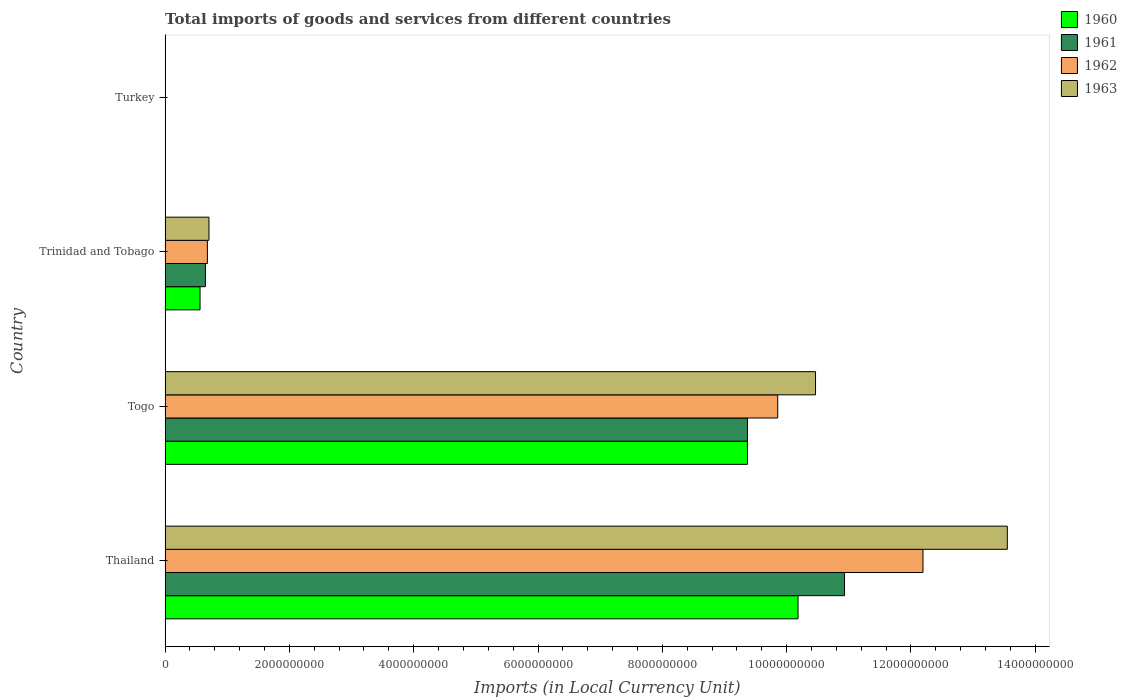Are the number of bars on each tick of the Y-axis equal?
Keep it short and to the point. Yes. How many bars are there on the 1st tick from the bottom?
Provide a succinct answer. 4. What is the label of the 3rd group of bars from the top?
Your response must be concise. Togo. What is the Amount of goods and services imports in 1960 in Togo?
Offer a terse response. 9.37e+09. Across all countries, what is the maximum Amount of goods and services imports in 1962?
Ensure brevity in your answer.  1.22e+1. Across all countries, what is the minimum Amount of goods and services imports in 1963?
Provide a short and direct response. 6500. In which country was the Amount of goods and services imports in 1960 maximum?
Provide a short and direct response. Thailand. In which country was the Amount of goods and services imports in 1961 minimum?
Make the answer very short. Turkey. What is the total Amount of goods and services imports in 1962 in the graph?
Offer a terse response. 2.27e+1. What is the difference between the Amount of goods and services imports in 1963 in Thailand and that in Trinidad and Tobago?
Your answer should be compact. 1.28e+1. What is the difference between the Amount of goods and services imports in 1960 in Turkey and the Amount of goods and services imports in 1962 in Thailand?
Make the answer very short. -1.22e+1. What is the average Amount of goods and services imports in 1960 per country?
Your answer should be compact. 5.03e+09. What is the difference between the Amount of goods and services imports in 1961 and Amount of goods and services imports in 1962 in Trinidad and Tobago?
Offer a very short reply. -3.17e+07. In how many countries, is the Amount of goods and services imports in 1963 greater than 9200000000 LCU?
Your response must be concise. 2. What is the ratio of the Amount of goods and services imports in 1960 in Thailand to that in Togo?
Give a very brief answer. 1.09. Is the difference between the Amount of goods and services imports in 1961 in Thailand and Trinidad and Tobago greater than the difference between the Amount of goods and services imports in 1962 in Thailand and Trinidad and Tobago?
Provide a succinct answer. No. What is the difference between the highest and the second highest Amount of goods and services imports in 1960?
Ensure brevity in your answer.  8.14e+08. What is the difference between the highest and the lowest Amount of goods and services imports in 1961?
Make the answer very short. 1.09e+1. In how many countries, is the Amount of goods and services imports in 1961 greater than the average Amount of goods and services imports in 1961 taken over all countries?
Your answer should be very brief. 2. Is the sum of the Amount of goods and services imports in 1962 in Trinidad and Tobago and Turkey greater than the maximum Amount of goods and services imports in 1961 across all countries?
Make the answer very short. No. Is it the case that in every country, the sum of the Amount of goods and services imports in 1961 and Amount of goods and services imports in 1962 is greater than the sum of Amount of goods and services imports in 1963 and Amount of goods and services imports in 1960?
Provide a succinct answer. No. What does the 3rd bar from the top in Trinidad and Tobago represents?
Keep it short and to the point. 1961. Are all the bars in the graph horizontal?
Make the answer very short. Yes. Are the values on the major ticks of X-axis written in scientific E-notation?
Your answer should be compact. No. Does the graph contain any zero values?
Your response must be concise. No. Does the graph contain grids?
Provide a short and direct response. No. How many legend labels are there?
Your answer should be very brief. 4. How are the legend labels stacked?
Offer a terse response. Vertical. What is the title of the graph?
Make the answer very short. Total imports of goods and services from different countries. Does "2002" appear as one of the legend labels in the graph?
Provide a succinct answer. No. What is the label or title of the X-axis?
Make the answer very short. Imports (in Local Currency Unit). What is the Imports (in Local Currency Unit) of 1960 in Thailand?
Your answer should be very brief. 1.02e+1. What is the Imports (in Local Currency Unit) of 1961 in Thailand?
Offer a terse response. 1.09e+1. What is the Imports (in Local Currency Unit) in 1962 in Thailand?
Provide a short and direct response. 1.22e+1. What is the Imports (in Local Currency Unit) of 1963 in Thailand?
Provide a succinct answer. 1.36e+1. What is the Imports (in Local Currency Unit) of 1960 in Togo?
Provide a short and direct response. 9.37e+09. What is the Imports (in Local Currency Unit) in 1961 in Togo?
Provide a short and direct response. 9.37e+09. What is the Imports (in Local Currency Unit) in 1962 in Togo?
Your answer should be compact. 9.86e+09. What is the Imports (in Local Currency Unit) of 1963 in Togo?
Your answer should be very brief. 1.05e+1. What is the Imports (in Local Currency Unit) of 1960 in Trinidad and Tobago?
Offer a terse response. 5.62e+08. What is the Imports (in Local Currency Unit) of 1961 in Trinidad and Tobago?
Your answer should be compact. 6.49e+08. What is the Imports (in Local Currency Unit) of 1962 in Trinidad and Tobago?
Your response must be concise. 6.81e+08. What is the Imports (in Local Currency Unit) in 1963 in Trinidad and Tobago?
Give a very brief answer. 7.06e+08. What is the Imports (in Local Currency Unit) of 1960 in Turkey?
Your response must be concise. 2500. What is the Imports (in Local Currency Unit) of 1961 in Turkey?
Keep it short and to the point. 4900. What is the Imports (in Local Currency Unit) of 1962 in Turkey?
Ensure brevity in your answer.  6400. What is the Imports (in Local Currency Unit) in 1963 in Turkey?
Offer a terse response. 6500. Across all countries, what is the maximum Imports (in Local Currency Unit) in 1960?
Offer a very short reply. 1.02e+1. Across all countries, what is the maximum Imports (in Local Currency Unit) of 1961?
Your answer should be very brief. 1.09e+1. Across all countries, what is the maximum Imports (in Local Currency Unit) in 1962?
Ensure brevity in your answer.  1.22e+1. Across all countries, what is the maximum Imports (in Local Currency Unit) in 1963?
Offer a terse response. 1.36e+1. Across all countries, what is the minimum Imports (in Local Currency Unit) in 1960?
Keep it short and to the point. 2500. Across all countries, what is the minimum Imports (in Local Currency Unit) of 1961?
Your answer should be very brief. 4900. Across all countries, what is the minimum Imports (in Local Currency Unit) in 1962?
Ensure brevity in your answer.  6400. Across all countries, what is the minimum Imports (in Local Currency Unit) in 1963?
Give a very brief answer. 6500. What is the total Imports (in Local Currency Unit) in 1960 in the graph?
Keep it short and to the point. 2.01e+1. What is the total Imports (in Local Currency Unit) in 1961 in the graph?
Ensure brevity in your answer.  2.10e+1. What is the total Imports (in Local Currency Unit) of 1962 in the graph?
Offer a very short reply. 2.27e+1. What is the total Imports (in Local Currency Unit) of 1963 in the graph?
Your answer should be compact. 2.47e+1. What is the difference between the Imports (in Local Currency Unit) in 1960 in Thailand and that in Togo?
Ensure brevity in your answer.  8.14e+08. What is the difference between the Imports (in Local Currency Unit) in 1961 in Thailand and that in Togo?
Make the answer very short. 1.56e+09. What is the difference between the Imports (in Local Currency Unit) of 1962 in Thailand and that in Togo?
Provide a succinct answer. 2.34e+09. What is the difference between the Imports (in Local Currency Unit) in 1963 in Thailand and that in Togo?
Your answer should be very brief. 3.09e+09. What is the difference between the Imports (in Local Currency Unit) in 1960 in Thailand and that in Trinidad and Tobago?
Your answer should be compact. 9.62e+09. What is the difference between the Imports (in Local Currency Unit) of 1961 in Thailand and that in Trinidad and Tobago?
Your answer should be very brief. 1.03e+1. What is the difference between the Imports (in Local Currency Unit) of 1962 in Thailand and that in Trinidad and Tobago?
Your answer should be very brief. 1.15e+1. What is the difference between the Imports (in Local Currency Unit) in 1963 in Thailand and that in Trinidad and Tobago?
Give a very brief answer. 1.28e+1. What is the difference between the Imports (in Local Currency Unit) in 1960 in Thailand and that in Turkey?
Make the answer very short. 1.02e+1. What is the difference between the Imports (in Local Currency Unit) in 1961 in Thailand and that in Turkey?
Your answer should be compact. 1.09e+1. What is the difference between the Imports (in Local Currency Unit) of 1962 in Thailand and that in Turkey?
Make the answer very short. 1.22e+1. What is the difference between the Imports (in Local Currency Unit) in 1963 in Thailand and that in Turkey?
Offer a terse response. 1.36e+1. What is the difference between the Imports (in Local Currency Unit) in 1960 in Togo and that in Trinidad and Tobago?
Your answer should be compact. 8.81e+09. What is the difference between the Imports (in Local Currency Unit) of 1961 in Togo and that in Trinidad and Tobago?
Provide a succinct answer. 8.72e+09. What is the difference between the Imports (in Local Currency Unit) in 1962 in Togo and that in Trinidad and Tobago?
Give a very brief answer. 9.18e+09. What is the difference between the Imports (in Local Currency Unit) of 1963 in Togo and that in Trinidad and Tobago?
Ensure brevity in your answer.  9.76e+09. What is the difference between the Imports (in Local Currency Unit) in 1960 in Togo and that in Turkey?
Provide a short and direct response. 9.37e+09. What is the difference between the Imports (in Local Currency Unit) in 1961 in Togo and that in Turkey?
Keep it short and to the point. 9.37e+09. What is the difference between the Imports (in Local Currency Unit) in 1962 in Togo and that in Turkey?
Your answer should be compact. 9.86e+09. What is the difference between the Imports (in Local Currency Unit) in 1963 in Togo and that in Turkey?
Make the answer very short. 1.05e+1. What is the difference between the Imports (in Local Currency Unit) of 1960 in Trinidad and Tobago and that in Turkey?
Your answer should be compact. 5.62e+08. What is the difference between the Imports (in Local Currency Unit) in 1961 in Trinidad and Tobago and that in Turkey?
Make the answer very short. 6.49e+08. What is the difference between the Imports (in Local Currency Unit) of 1962 in Trinidad and Tobago and that in Turkey?
Your answer should be compact. 6.81e+08. What is the difference between the Imports (in Local Currency Unit) of 1963 in Trinidad and Tobago and that in Turkey?
Your answer should be compact. 7.06e+08. What is the difference between the Imports (in Local Currency Unit) in 1960 in Thailand and the Imports (in Local Currency Unit) in 1961 in Togo?
Keep it short and to the point. 8.14e+08. What is the difference between the Imports (in Local Currency Unit) of 1960 in Thailand and the Imports (in Local Currency Unit) of 1962 in Togo?
Provide a succinct answer. 3.27e+08. What is the difference between the Imports (in Local Currency Unit) of 1960 in Thailand and the Imports (in Local Currency Unit) of 1963 in Togo?
Provide a short and direct response. -2.81e+08. What is the difference between the Imports (in Local Currency Unit) in 1961 in Thailand and the Imports (in Local Currency Unit) in 1962 in Togo?
Offer a terse response. 1.08e+09. What is the difference between the Imports (in Local Currency Unit) of 1961 in Thailand and the Imports (in Local Currency Unit) of 1963 in Togo?
Your answer should be compact. 4.67e+08. What is the difference between the Imports (in Local Currency Unit) in 1962 in Thailand and the Imports (in Local Currency Unit) in 1963 in Togo?
Provide a short and direct response. 1.73e+09. What is the difference between the Imports (in Local Currency Unit) of 1960 in Thailand and the Imports (in Local Currency Unit) of 1961 in Trinidad and Tobago?
Your answer should be compact. 9.54e+09. What is the difference between the Imports (in Local Currency Unit) in 1960 in Thailand and the Imports (in Local Currency Unit) in 1962 in Trinidad and Tobago?
Offer a very short reply. 9.50e+09. What is the difference between the Imports (in Local Currency Unit) of 1960 in Thailand and the Imports (in Local Currency Unit) of 1963 in Trinidad and Tobago?
Offer a very short reply. 9.48e+09. What is the difference between the Imports (in Local Currency Unit) of 1961 in Thailand and the Imports (in Local Currency Unit) of 1962 in Trinidad and Tobago?
Provide a short and direct response. 1.03e+1. What is the difference between the Imports (in Local Currency Unit) of 1961 in Thailand and the Imports (in Local Currency Unit) of 1963 in Trinidad and Tobago?
Your response must be concise. 1.02e+1. What is the difference between the Imports (in Local Currency Unit) of 1962 in Thailand and the Imports (in Local Currency Unit) of 1963 in Trinidad and Tobago?
Keep it short and to the point. 1.15e+1. What is the difference between the Imports (in Local Currency Unit) of 1960 in Thailand and the Imports (in Local Currency Unit) of 1961 in Turkey?
Provide a short and direct response. 1.02e+1. What is the difference between the Imports (in Local Currency Unit) of 1960 in Thailand and the Imports (in Local Currency Unit) of 1962 in Turkey?
Your response must be concise. 1.02e+1. What is the difference between the Imports (in Local Currency Unit) in 1960 in Thailand and the Imports (in Local Currency Unit) in 1963 in Turkey?
Your answer should be very brief. 1.02e+1. What is the difference between the Imports (in Local Currency Unit) in 1961 in Thailand and the Imports (in Local Currency Unit) in 1962 in Turkey?
Provide a short and direct response. 1.09e+1. What is the difference between the Imports (in Local Currency Unit) of 1961 in Thailand and the Imports (in Local Currency Unit) of 1963 in Turkey?
Provide a succinct answer. 1.09e+1. What is the difference between the Imports (in Local Currency Unit) of 1962 in Thailand and the Imports (in Local Currency Unit) of 1963 in Turkey?
Offer a terse response. 1.22e+1. What is the difference between the Imports (in Local Currency Unit) in 1960 in Togo and the Imports (in Local Currency Unit) in 1961 in Trinidad and Tobago?
Your answer should be compact. 8.72e+09. What is the difference between the Imports (in Local Currency Unit) in 1960 in Togo and the Imports (in Local Currency Unit) in 1962 in Trinidad and Tobago?
Offer a terse response. 8.69e+09. What is the difference between the Imports (in Local Currency Unit) of 1960 in Togo and the Imports (in Local Currency Unit) of 1963 in Trinidad and Tobago?
Keep it short and to the point. 8.66e+09. What is the difference between the Imports (in Local Currency Unit) in 1961 in Togo and the Imports (in Local Currency Unit) in 1962 in Trinidad and Tobago?
Offer a terse response. 8.69e+09. What is the difference between the Imports (in Local Currency Unit) of 1961 in Togo and the Imports (in Local Currency Unit) of 1963 in Trinidad and Tobago?
Keep it short and to the point. 8.66e+09. What is the difference between the Imports (in Local Currency Unit) in 1962 in Togo and the Imports (in Local Currency Unit) in 1963 in Trinidad and Tobago?
Your answer should be compact. 9.15e+09. What is the difference between the Imports (in Local Currency Unit) in 1960 in Togo and the Imports (in Local Currency Unit) in 1961 in Turkey?
Give a very brief answer. 9.37e+09. What is the difference between the Imports (in Local Currency Unit) of 1960 in Togo and the Imports (in Local Currency Unit) of 1962 in Turkey?
Offer a terse response. 9.37e+09. What is the difference between the Imports (in Local Currency Unit) of 1960 in Togo and the Imports (in Local Currency Unit) of 1963 in Turkey?
Offer a terse response. 9.37e+09. What is the difference between the Imports (in Local Currency Unit) in 1961 in Togo and the Imports (in Local Currency Unit) in 1962 in Turkey?
Keep it short and to the point. 9.37e+09. What is the difference between the Imports (in Local Currency Unit) of 1961 in Togo and the Imports (in Local Currency Unit) of 1963 in Turkey?
Your response must be concise. 9.37e+09. What is the difference between the Imports (in Local Currency Unit) of 1962 in Togo and the Imports (in Local Currency Unit) of 1963 in Turkey?
Your response must be concise. 9.86e+09. What is the difference between the Imports (in Local Currency Unit) in 1960 in Trinidad and Tobago and the Imports (in Local Currency Unit) in 1961 in Turkey?
Keep it short and to the point. 5.62e+08. What is the difference between the Imports (in Local Currency Unit) of 1960 in Trinidad and Tobago and the Imports (in Local Currency Unit) of 1962 in Turkey?
Your response must be concise. 5.62e+08. What is the difference between the Imports (in Local Currency Unit) of 1960 in Trinidad and Tobago and the Imports (in Local Currency Unit) of 1963 in Turkey?
Offer a very short reply. 5.62e+08. What is the difference between the Imports (in Local Currency Unit) in 1961 in Trinidad and Tobago and the Imports (in Local Currency Unit) in 1962 in Turkey?
Make the answer very short. 6.49e+08. What is the difference between the Imports (in Local Currency Unit) of 1961 in Trinidad and Tobago and the Imports (in Local Currency Unit) of 1963 in Turkey?
Offer a very short reply. 6.49e+08. What is the difference between the Imports (in Local Currency Unit) in 1962 in Trinidad and Tobago and the Imports (in Local Currency Unit) in 1963 in Turkey?
Provide a short and direct response. 6.81e+08. What is the average Imports (in Local Currency Unit) in 1960 per country?
Your answer should be compact. 5.03e+09. What is the average Imports (in Local Currency Unit) of 1961 per country?
Offer a terse response. 5.24e+09. What is the average Imports (in Local Currency Unit) of 1962 per country?
Make the answer very short. 5.68e+09. What is the average Imports (in Local Currency Unit) of 1963 per country?
Your answer should be very brief. 6.18e+09. What is the difference between the Imports (in Local Currency Unit) of 1960 and Imports (in Local Currency Unit) of 1961 in Thailand?
Make the answer very short. -7.48e+08. What is the difference between the Imports (in Local Currency Unit) in 1960 and Imports (in Local Currency Unit) in 1962 in Thailand?
Offer a terse response. -2.01e+09. What is the difference between the Imports (in Local Currency Unit) in 1960 and Imports (in Local Currency Unit) in 1963 in Thailand?
Your answer should be very brief. -3.37e+09. What is the difference between the Imports (in Local Currency Unit) in 1961 and Imports (in Local Currency Unit) in 1962 in Thailand?
Your response must be concise. -1.26e+09. What is the difference between the Imports (in Local Currency Unit) of 1961 and Imports (in Local Currency Unit) of 1963 in Thailand?
Your answer should be compact. -2.62e+09. What is the difference between the Imports (in Local Currency Unit) in 1962 and Imports (in Local Currency Unit) in 1963 in Thailand?
Your answer should be compact. -1.36e+09. What is the difference between the Imports (in Local Currency Unit) in 1960 and Imports (in Local Currency Unit) in 1962 in Togo?
Offer a terse response. -4.87e+08. What is the difference between the Imports (in Local Currency Unit) in 1960 and Imports (in Local Currency Unit) in 1963 in Togo?
Make the answer very short. -1.10e+09. What is the difference between the Imports (in Local Currency Unit) in 1961 and Imports (in Local Currency Unit) in 1962 in Togo?
Keep it short and to the point. -4.87e+08. What is the difference between the Imports (in Local Currency Unit) in 1961 and Imports (in Local Currency Unit) in 1963 in Togo?
Keep it short and to the point. -1.10e+09. What is the difference between the Imports (in Local Currency Unit) of 1962 and Imports (in Local Currency Unit) of 1963 in Togo?
Your answer should be very brief. -6.08e+08. What is the difference between the Imports (in Local Currency Unit) in 1960 and Imports (in Local Currency Unit) in 1961 in Trinidad and Tobago?
Provide a succinct answer. -8.67e+07. What is the difference between the Imports (in Local Currency Unit) of 1960 and Imports (in Local Currency Unit) of 1962 in Trinidad and Tobago?
Offer a very short reply. -1.18e+08. What is the difference between the Imports (in Local Currency Unit) of 1960 and Imports (in Local Currency Unit) of 1963 in Trinidad and Tobago?
Make the answer very short. -1.44e+08. What is the difference between the Imports (in Local Currency Unit) in 1961 and Imports (in Local Currency Unit) in 1962 in Trinidad and Tobago?
Provide a succinct answer. -3.17e+07. What is the difference between the Imports (in Local Currency Unit) in 1961 and Imports (in Local Currency Unit) in 1963 in Trinidad and Tobago?
Keep it short and to the point. -5.69e+07. What is the difference between the Imports (in Local Currency Unit) of 1962 and Imports (in Local Currency Unit) of 1963 in Trinidad and Tobago?
Provide a succinct answer. -2.52e+07. What is the difference between the Imports (in Local Currency Unit) of 1960 and Imports (in Local Currency Unit) of 1961 in Turkey?
Keep it short and to the point. -2400. What is the difference between the Imports (in Local Currency Unit) in 1960 and Imports (in Local Currency Unit) in 1962 in Turkey?
Your answer should be compact. -3900. What is the difference between the Imports (in Local Currency Unit) of 1960 and Imports (in Local Currency Unit) of 1963 in Turkey?
Your response must be concise. -4000. What is the difference between the Imports (in Local Currency Unit) of 1961 and Imports (in Local Currency Unit) of 1962 in Turkey?
Offer a terse response. -1500. What is the difference between the Imports (in Local Currency Unit) in 1961 and Imports (in Local Currency Unit) in 1963 in Turkey?
Offer a very short reply. -1600. What is the difference between the Imports (in Local Currency Unit) of 1962 and Imports (in Local Currency Unit) of 1963 in Turkey?
Offer a terse response. -100. What is the ratio of the Imports (in Local Currency Unit) in 1960 in Thailand to that in Togo?
Keep it short and to the point. 1.09. What is the ratio of the Imports (in Local Currency Unit) of 1961 in Thailand to that in Togo?
Ensure brevity in your answer.  1.17. What is the ratio of the Imports (in Local Currency Unit) of 1962 in Thailand to that in Togo?
Provide a succinct answer. 1.24. What is the ratio of the Imports (in Local Currency Unit) in 1963 in Thailand to that in Togo?
Ensure brevity in your answer.  1.29. What is the ratio of the Imports (in Local Currency Unit) of 1960 in Thailand to that in Trinidad and Tobago?
Provide a short and direct response. 18.11. What is the ratio of the Imports (in Local Currency Unit) in 1961 in Thailand to that in Trinidad and Tobago?
Provide a succinct answer. 16.85. What is the ratio of the Imports (in Local Currency Unit) in 1962 in Thailand to that in Trinidad and Tobago?
Your response must be concise. 17.92. What is the ratio of the Imports (in Local Currency Unit) of 1963 in Thailand to that in Trinidad and Tobago?
Offer a very short reply. 19.2. What is the ratio of the Imports (in Local Currency Unit) in 1960 in Thailand to that in Turkey?
Offer a very short reply. 4.07e+06. What is the ratio of the Imports (in Local Currency Unit) of 1961 in Thailand to that in Turkey?
Keep it short and to the point. 2.23e+06. What is the ratio of the Imports (in Local Currency Unit) in 1962 in Thailand to that in Turkey?
Make the answer very short. 1.91e+06. What is the ratio of the Imports (in Local Currency Unit) of 1963 in Thailand to that in Turkey?
Ensure brevity in your answer.  2.08e+06. What is the ratio of the Imports (in Local Currency Unit) in 1960 in Togo to that in Trinidad and Tobago?
Offer a very short reply. 16.67. What is the ratio of the Imports (in Local Currency Unit) of 1961 in Togo to that in Trinidad and Tobago?
Provide a succinct answer. 14.44. What is the ratio of the Imports (in Local Currency Unit) of 1962 in Togo to that in Trinidad and Tobago?
Make the answer very short. 14.48. What is the ratio of the Imports (in Local Currency Unit) in 1963 in Togo to that in Trinidad and Tobago?
Provide a short and direct response. 14.83. What is the ratio of the Imports (in Local Currency Unit) in 1960 in Togo to that in Turkey?
Provide a short and direct response. 3.75e+06. What is the ratio of the Imports (in Local Currency Unit) in 1961 in Togo to that in Turkey?
Ensure brevity in your answer.  1.91e+06. What is the ratio of the Imports (in Local Currency Unit) of 1962 in Togo to that in Turkey?
Provide a succinct answer. 1.54e+06. What is the ratio of the Imports (in Local Currency Unit) of 1963 in Togo to that in Turkey?
Ensure brevity in your answer.  1.61e+06. What is the ratio of the Imports (in Local Currency Unit) of 1960 in Trinidad and Tobago to that in Turkey?
Offer a terse response. 2.25e+05. What is the ratio of the Imports (in Local Currency Unit) of 1961 in Trinidad and Tobago to that in Turkey?
Your answer should be compact. 1.32e+05. What is the ratio of the Imports (in Local Currency Unit) in 1962 in Trinidad and Tobago to that in Turkey?
Your answer should be compact. 1.06e+05. What is the ratio of the Imports (in Local Currency Unit) in 1963 in Trinidad and Tobago to that in Turkey?
Provide a succinct answer. 1.09e+05. What is the difference between the highest and the second highest Imports (in Local Currency Unit) in 1960?
Your response must be concise. 8.14e+08. What is the difference between the highest and the second highest Imports (in Local Currency Unit) of 1961?
Provide a short and direct response. 1.56e+09. What is the difference between the highest and the second highest Imports (in Local Currency Unit) in 1962?
Offer a very short reply. 2.34e+09. What is the difference between the highest and the second highest Imports (in Local Currency Unit) in 1963?
Your answer should be very brief. 3.09e+09. What is the difference between the highest and the lowest Imports (in Local Currency Unit) of 1960?
Offer a terse response. 1.02e+1. What is the difference between the highest and the lowest Imports (in Local Currency Unit) in 1961?
Make the answer very short. 1.09e+1. What is the difference between the highest and the lowest Imports (in Local Currency Unit) of 1962?
Your answer should be very brief. 1.22e+1. What is the difference between the highest and the lowest Imports (in Local Currency Unit) in 1963?
Ensure brevity in your answer.  1.36e+1. 